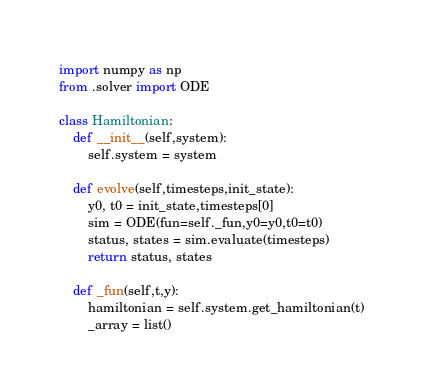Convert code to text. <code><loc_0><loc_0><loc_500><loc_500><_Python_>import numpy as np 
from .solver import ODE

class Hamiltonian:
    def __init__(self,system):
        self.system = system

    def evolve(self,timesteps,init_state):
        y0, t0 = init_state,timesteps[0]
        sim = ODE(fun=self._fun,y0=y0,t0=t0)
        status, states = sim.evaluate(timesteps)
        return status, states

    def _fun(self,t,y):
        hamiltonian = self.system.get_hamiltonian(t)
        _array = list()</code> 